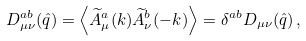<formula> <loc_0><loc_0><loc_500><loc_500>D ^ { a b } _ { \mu \nu } ( \hat { q } ) = \left \langle \widetilde { A } ^ { a } _ { \mu } ( k ) \widetilde { A } ^ { b } _ { \nu } ( - k ) \right \rangle = \delta ^ { a b } D _ { \mu \nu } ( \hat { q } ) \, ,</formula> 